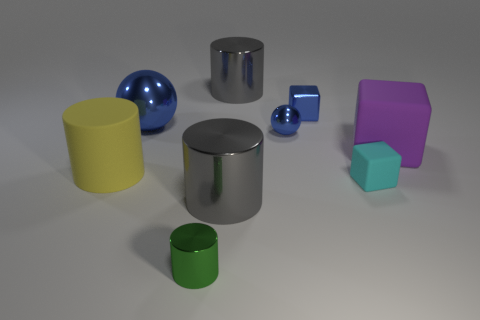Subtract all rubber cubes. How many cubes are left? 1 Add 1 green metallic cylinders. How many objects exist? 10 Subtract all cyan cubes. How many cubes are left? 2 Subtract 2 blocks. How many blocks are left? 1 Subtract all blue cylinders. Subtract all yellow spheres. How many cylinders are left? 4 Subtract all brown cubes. How many yellow cylinders are left? 1 Subtract all big cyan matte things. Subtract all large blue balls. How many objects are left? 8 Add 8 cyan objects. How many cyan objects are left? 9 Add 8 balls. How many balls exist? 10 Subtract 0 red cubes. How many objects are left? 9 